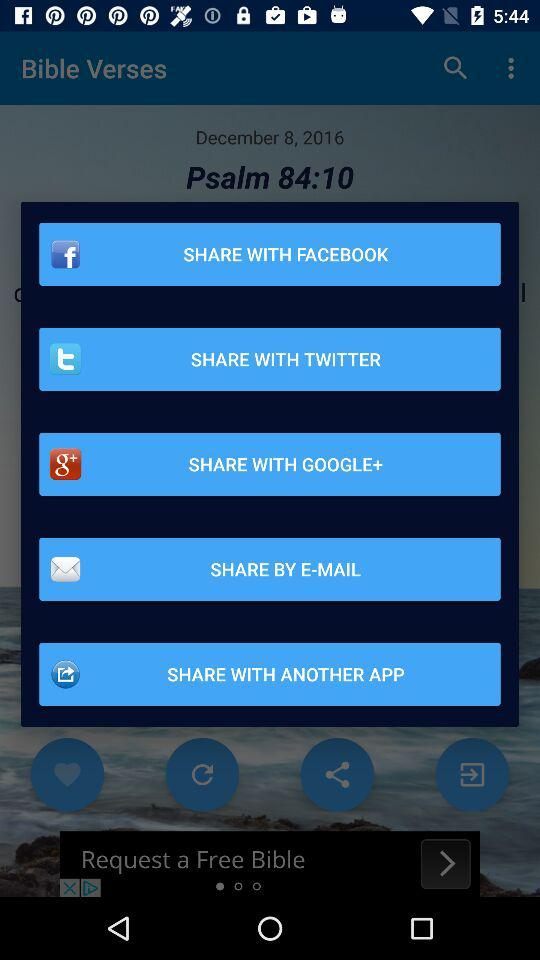What are the sharing options? The sharing options are "FACEBOOK", "TWITTER", "GOOGLE+" and "E-MAIL". 